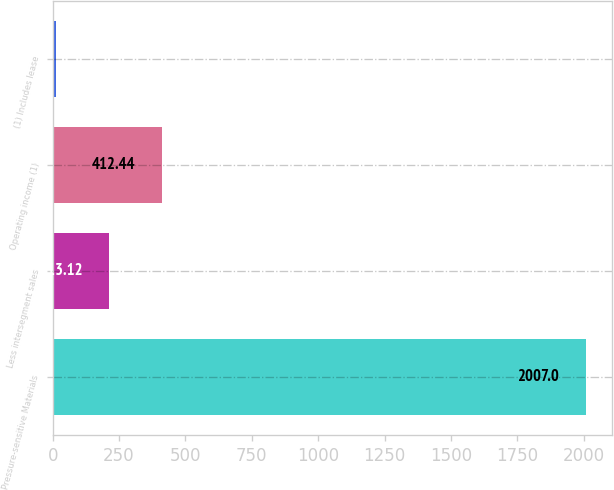Convert chart to OTSL. <chart><loc_0><loc_0><loc_500><loc_500><bar_chart><fcel>Pressure-sensitive Materials<fcel>Less intersegment sales<fcel>Operating income (1)<fcel>(1) Includes lease<nl><fcel>2007<fcel>213.12<fcel>412.44<fcel>13.8<nl></chart> 